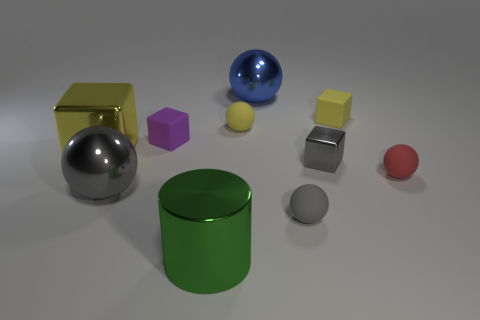There is a rubber thing that is both to the left of the gray rubber thing and behind the tiny purple block; how big is it?
Give a very brief answer. Small. Are there more shiny cubes right of the tiny purple matte object than big cylinders behind the tiny yellow block?
Your response must be concise. Yes. There is a tiny purple object; is it the same shape as the yellow rubber thing to the left of the small metallic block?
Offer a terse response. No. How many other objects are the same shape as the small gray matte object?
Offer a terse response. 4. There is a big metallic thing that is both behind the tiny gray shiny cube and left of the large green shiny cylinder; what is its color?
Your response must be concise. Yellow. What color is the small metal thing?
Provide a succinct answer. Gray. Is the small gray sphere made of the same material as the small yellow thing on the left side of the tiny yellow matte cube?
Your response must be concise. Yes. There is a tiny purple thing that is the same material as the tiny red thing; what shape is it?
Your response must be concise. Cube. There is a metal cube that is the same size as the red rubber object; what is its color?
Your answer should be compact. Gray. Do the shiny ball right of the shiny cylinder and the big yellow object have the same size?
Your response must be concise. Yes. 